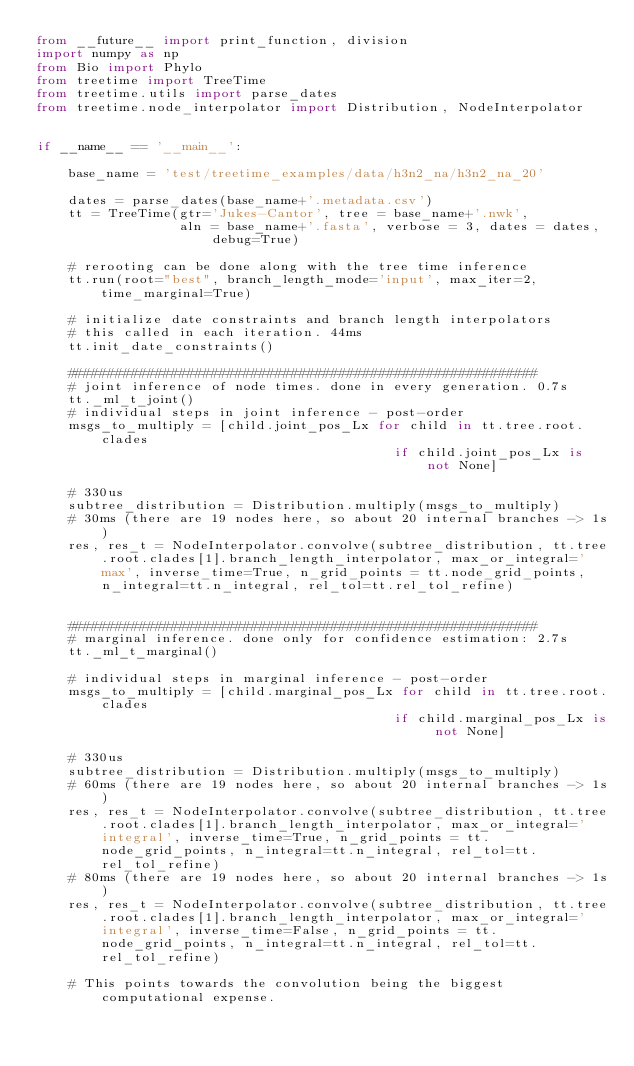<code> <loc_0><loc_0><loc_500><loc_500><_Python_>from __future__ import print_function, division
import numpy as np
from Bio import Phylo
from treetime import TreeTime
from treetime.utils import parse_dates
from treetime.node_interpolator import Distribution, NodeInterpolator


if __name__ == '__main__':

    base_name = 'test/treetime_examples/data/h3n2_na/h3n2_na_20'

    dates = parse_dates(base_name+'.metadata.csv')
    tt = TreeTime(gtr='Jukes-Cantor', tree = base_name+'.nwk',
                  aln = base_name+'.fasta', verbose = 3, dates = dates, debug=True)

    # rerooting can be done along with the tree time inference
    tt.run(root="best", branch_length_mode='input', max_iter=2, time_marginal=True)

    # initialize date constraints and branch length interpolators
    # this called in each iteration. 44ms
    tt.init_date_constraints()

    ###########################################################
    # joint inference of node times. done in every generation. 0.7s
    tt._ml_t_joint()
    # individual steps in joint inference - post-order
    msgs_to_multiply = [child.joint_pos_Lx for child in tt.tree.root.clades
                                             if child.joint_pos_Lx is not None]

    # 330us
    subtree_distribution = Distribution.multiply(msgs_to_multiply)
    # 30ms (there are 19 nodes here, so about 20 internal branches -> 1s)
    res, res_t = NodeInterpolator.convolve(subtree_distribution, tt.tree.root.clades[1].branch_length_interpolator, max_or_integral='max', inverse_time=True, n_grid_points = tt.node_grid_points, n_integral=tt.n_integral, rel_tol=tt.rel_tol_refine)


    ###########################################################
    # marginal inference. done only for confidence estimation: 2.7s
    tt._ml_t_marginal()

    # individual steps in marginal inference - post-order
    msgs_to_multiply = [child.marginal_pos_Lx for child in tt.tree.root.clades
                                             if child.marginal_pos_Lx is not None]

    # 330us
    subtree_distribution = Distribution.multiply(msgs_to_multiply)
    # 60ms (there are 19 nodes here, so about 20 internal branches -> 1s)
    res, res_t = NodeInterpolator.convolve(subtree_distribution, tt.tree.root.clades[1].branch_length_interpolator, max_or_integral='integral', inverse_time=True, n_grid_points = tt.node_grid_points, n_integral=tt.n_integral, rel_tol=tt.rel_tol_refine)
    # 80ms (there are 19 nodes here, so about 20 internal branches -> 1s)
    res, res_t = NodeInterpolator.convolve(subtree_distribution, tt.tree.root.clades[1].branch_length_interpolator, max_or_integral='integral', inverse_time=False, n_grid_points = tt.node_grid_points, n_integral=tt.n_integral, rel_tol=tt.rel_tol_refine)

    # This points towards the convolution being the biggest computational expense. 



</code> 